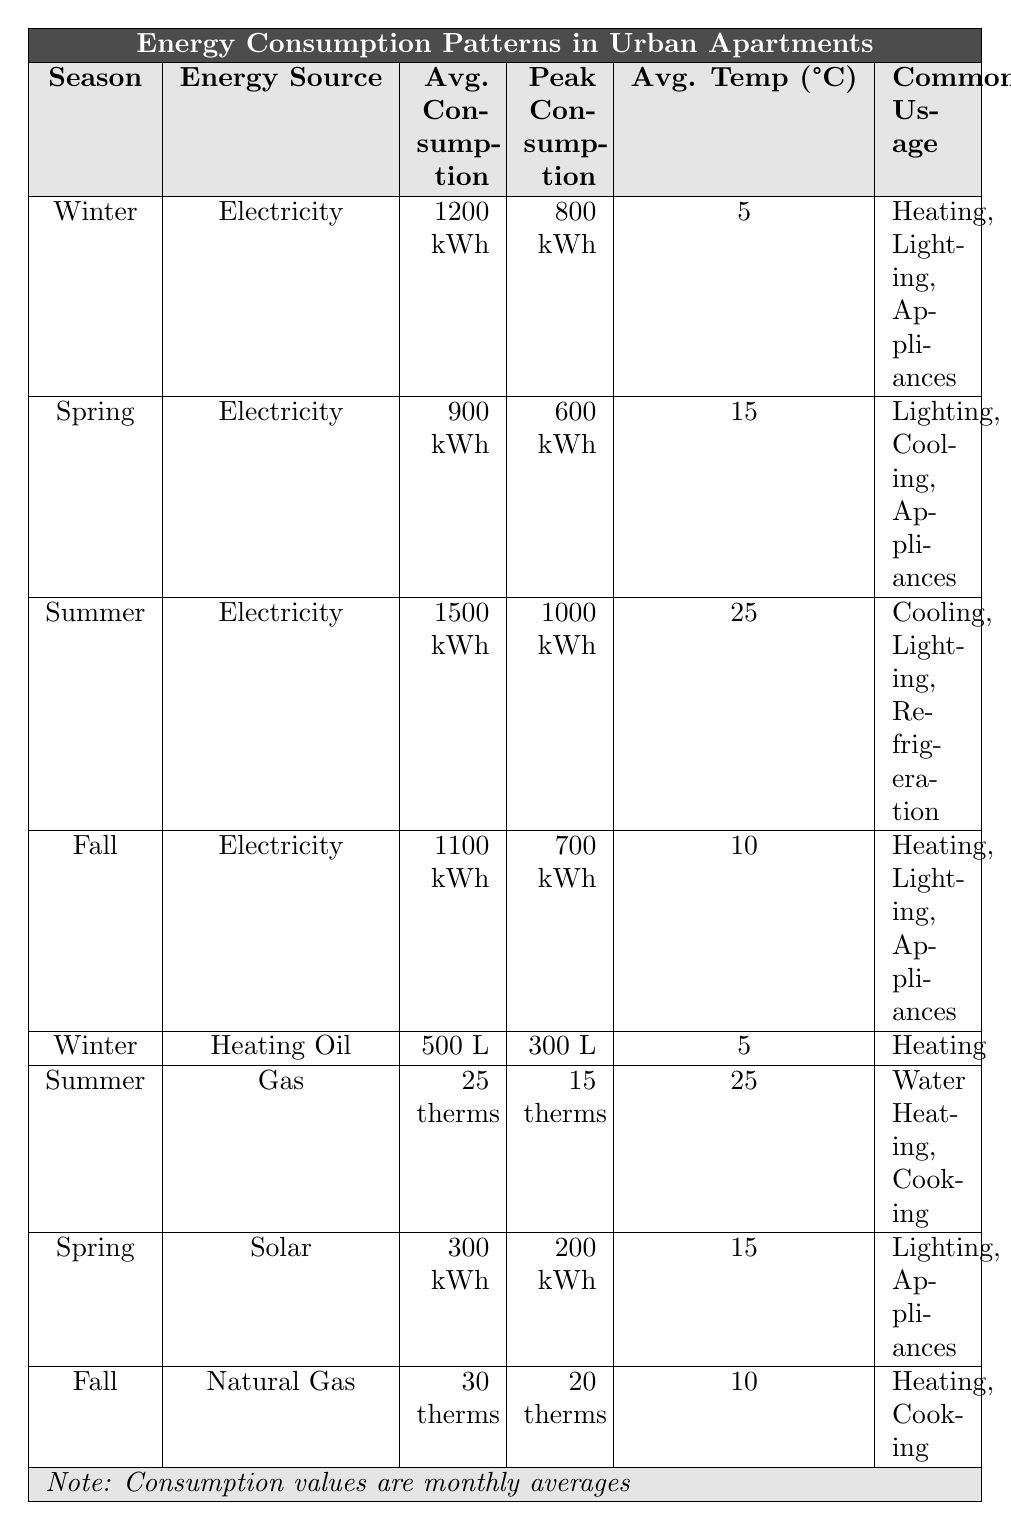What is the average electricity consumption in summer? In the table, for the summer season under electricity, the average consumption is listed as 1500 kWh.
Answer: 1500 kWh Which season has the highest peak electricity consumption? Referring to the peak consumptions for electricity, summer shows the highest value of 1000 kWh compared to winter (800 kWh), spring (600 kWh), and fall (700 kWh).
Answer: Summer Is the average temperature higher in summer or winter? The average temperature for summer is 25°C and for winter, it is 5°C. Comparing these two values, summer has the higher temperature.
Answer: Summer What is the total average consumption for electricity in winter? The total average consumption for winter includes both electricity and heating oil. For electricity, it is 1200 kWh, and for heating oil, it is 500 liters. Since they are different units, we can only report the electricity consumption directly.
Answer: 1200 kWh Which energy source is used for water heating in the summer? The table states that Gas is the energy source for water heating in the summer with an average consumption of 25 therms.
Answer: Gas How much more electricity is consumed in summer compared to spring? The average consumption in summer is 1500 kWh and in spring it is 900 kWh. The difference is 1500 - 900 = 600 kWh.
Answer: 600 kWh Is it true that heating oil is only used in winter? According to the table, heating oil is listed as an energy source exclusively for winter with common usage for heating. Therefore, this statement is true.
Answer: Yes What is the average electricity consumption across the four seasons? We will calculate the average electricity consumption: (1200 + 900 + 1500 + 1100) / 4 = 1200 kWh. Hence, the average for these four seasons is 1200 kWh.
Answer: 1200 kWh Which season has the lowest average temperature and what is it? The fall season has the lowest average temperature listed at 10°C, while winter is at 5°C but has higher consumption, indicating that fall has the lowest temperature overall.
Answer: 10°C How much total standard energy sources (excluding solar and heating oil) are consumed in spring? In spring, the average electricity consumption is 900 kWh, and for solar, it is 300 kWh. The total for spring is 900 + 300 = 1200 kWh.
Answer: 1200 kWh 